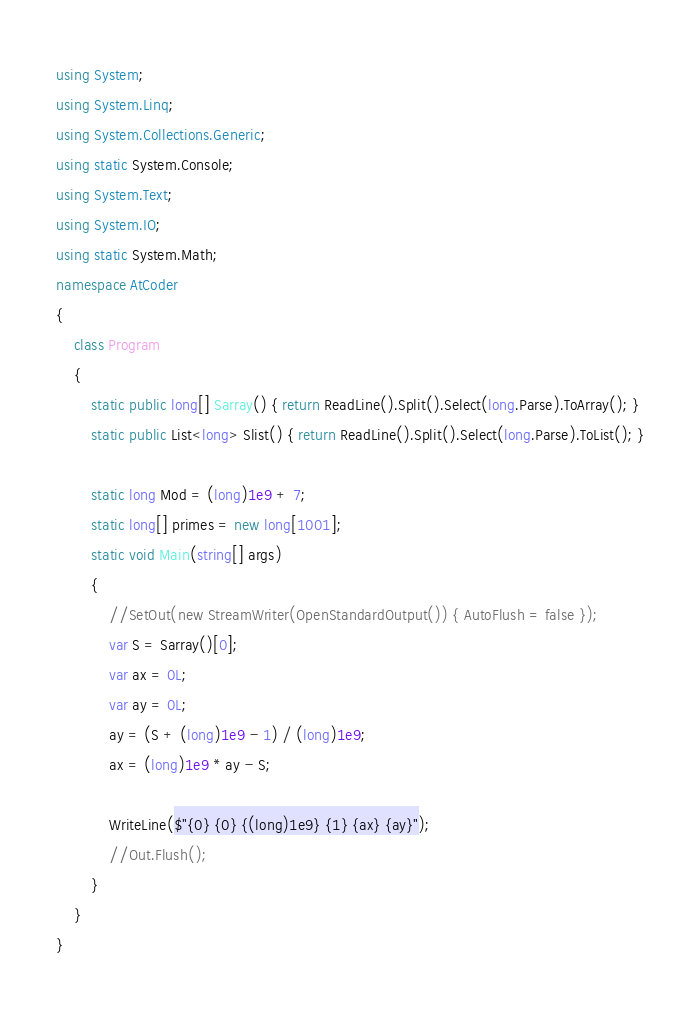Convert code to text. <code><loc_0><loc_0><loc_500><loc_500><_C#_>using System;
using System.Linq;
using System.Collections.Generic;
using static System.Console;
using System.Text;
using System.IO;
using static System.Math;
namespace AtCoder
{
    class Program
    {
        static public long[] Sarray() { return ReadLine().Split().Select(long.Parse).ToArray(); }
        static public List<long> Slist() { return ReadLine().Split().Select(long.Parse).ToList(); }

        static long Mod = (long)1e9 + 7;
        static long[] primes = new long[1001];
        static void Main(string[] args)
        {
            //SetOut(new StreamWriter(OpenStandardOutput()) { AutoFlush = false });
            var S = Sarray()[0];
            var ax = 0L;
            var ay = 0L;
            ay = (S + (long)1e9 - 1) / (long)1e9;
            ax = (long)1e9 * ay - S;

            WriteLine($"{0} {0} {(long)1e9} {1} {ax} {ay}");
            //Out.Flush();
        }
    }
}</code> 